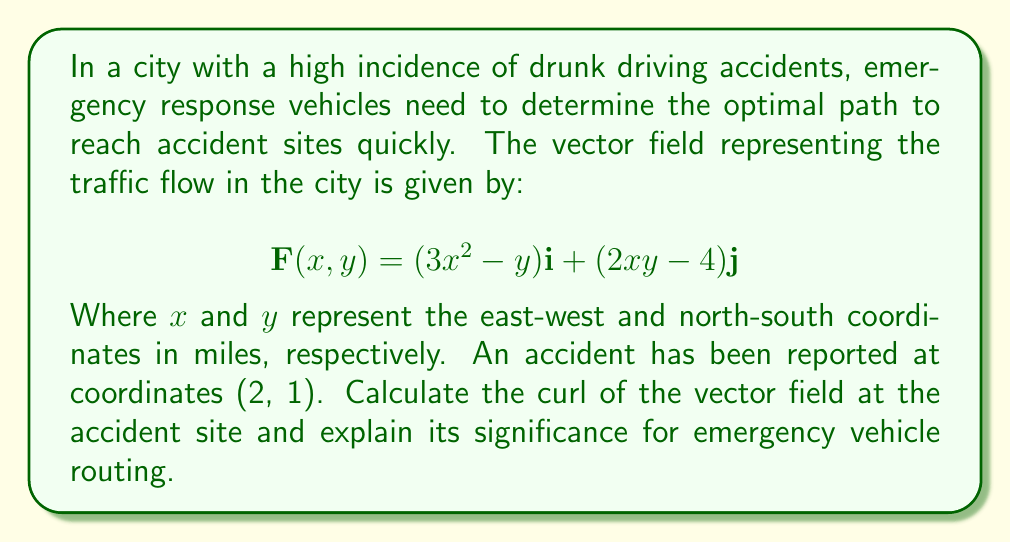Teach me how to tackle this problem. To solve this problem, we need to calculate the curl of the vector field at the given point. The curl of a vector field in two dimensions is defined as:

$$\text{curl } \mathbf{F} = \frac{\partial Q}{\partial x} - \frac{\partial P}{\partial y}$$

Where $P$ and $Q$ are the components of the vector field $\mathbf{F}(x,y) = P(x,y)\mathbf{i} + Q(x,y)\mathbf{j}$.

In this case:
$P(x,y) = 3x^2 - y$
$Q(x,y) = 2xy - 4$

Step 1: Calculate $\frac{\partial Q}{\partial x}$
$$\frac{\partial Q}{\partial x} = \frac{\partial}{\partial x}(2xy - 4) = 2y$$

Step 2: Calculate $\frac{\partial P}{\partial y}$
$$\frac{\partial P}{\partial y} = \frac{\partial}{\partial y}(3x^2 - y) = -1$$

Step 3: Calculate the curl
$$\text{curl } \mathbf{F} = \frac{\partial Q}{\partial x} - \frac{\partial P}{\partial y} = 2y - (-1) = 2y + 1$$

Step 4: Evaluate the curl at the accident site (2, 1)
$$\text{curl } \mathbf{F}(2,1) = 2(1) + 1 = 3$$

The positive curl indicates a counterclockwise rotation in the vector field at the accident site. This information is crucial for emergency responders as it suggests:

1. The traffic flow around the accident site has a rotational component, which may cause congestion.
2. Emergency vehicles should approach the site considering this rotation to avoid getting caught in traffic eddies.
3. A counterclockwise rotation might indicate that approaching the site from the west or south could be more efficient than from the east or north.

Understanding this curl helps emergency responders optimize their route, potentially reducing response times and saving lives in drunk driving accident scenarios.
Answer: The curl of the vector field at the accident site (2, 1) is 3, indicating a counterclockwise rotation in the traffic flow. 